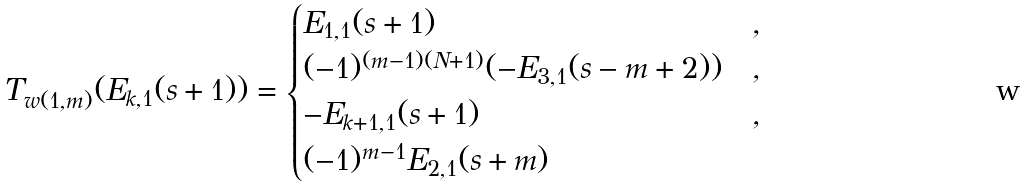<formula> <loc_0><loc_0><loc_500><loc_500>T _ { w ( 1 , m ) } ( E _ { k , 1 } ( s + 1 ) ) = \begin{cases} E _ { 1 , 1 } ( s + 1 ) & , \\ ( - 1 ) ^ { ( m - 1 ) ( N + 1 ) } ( - E _ { 3 , 1 } ( s - m + 2 ) ) & , \\ - E _ { k + 1 , 1 } ( s + 1 ) & , \\ ( - 1 ) ^ { m - 1 } E _ { 2 , 1 } ( s + m ) & \end{cases}</formula> 